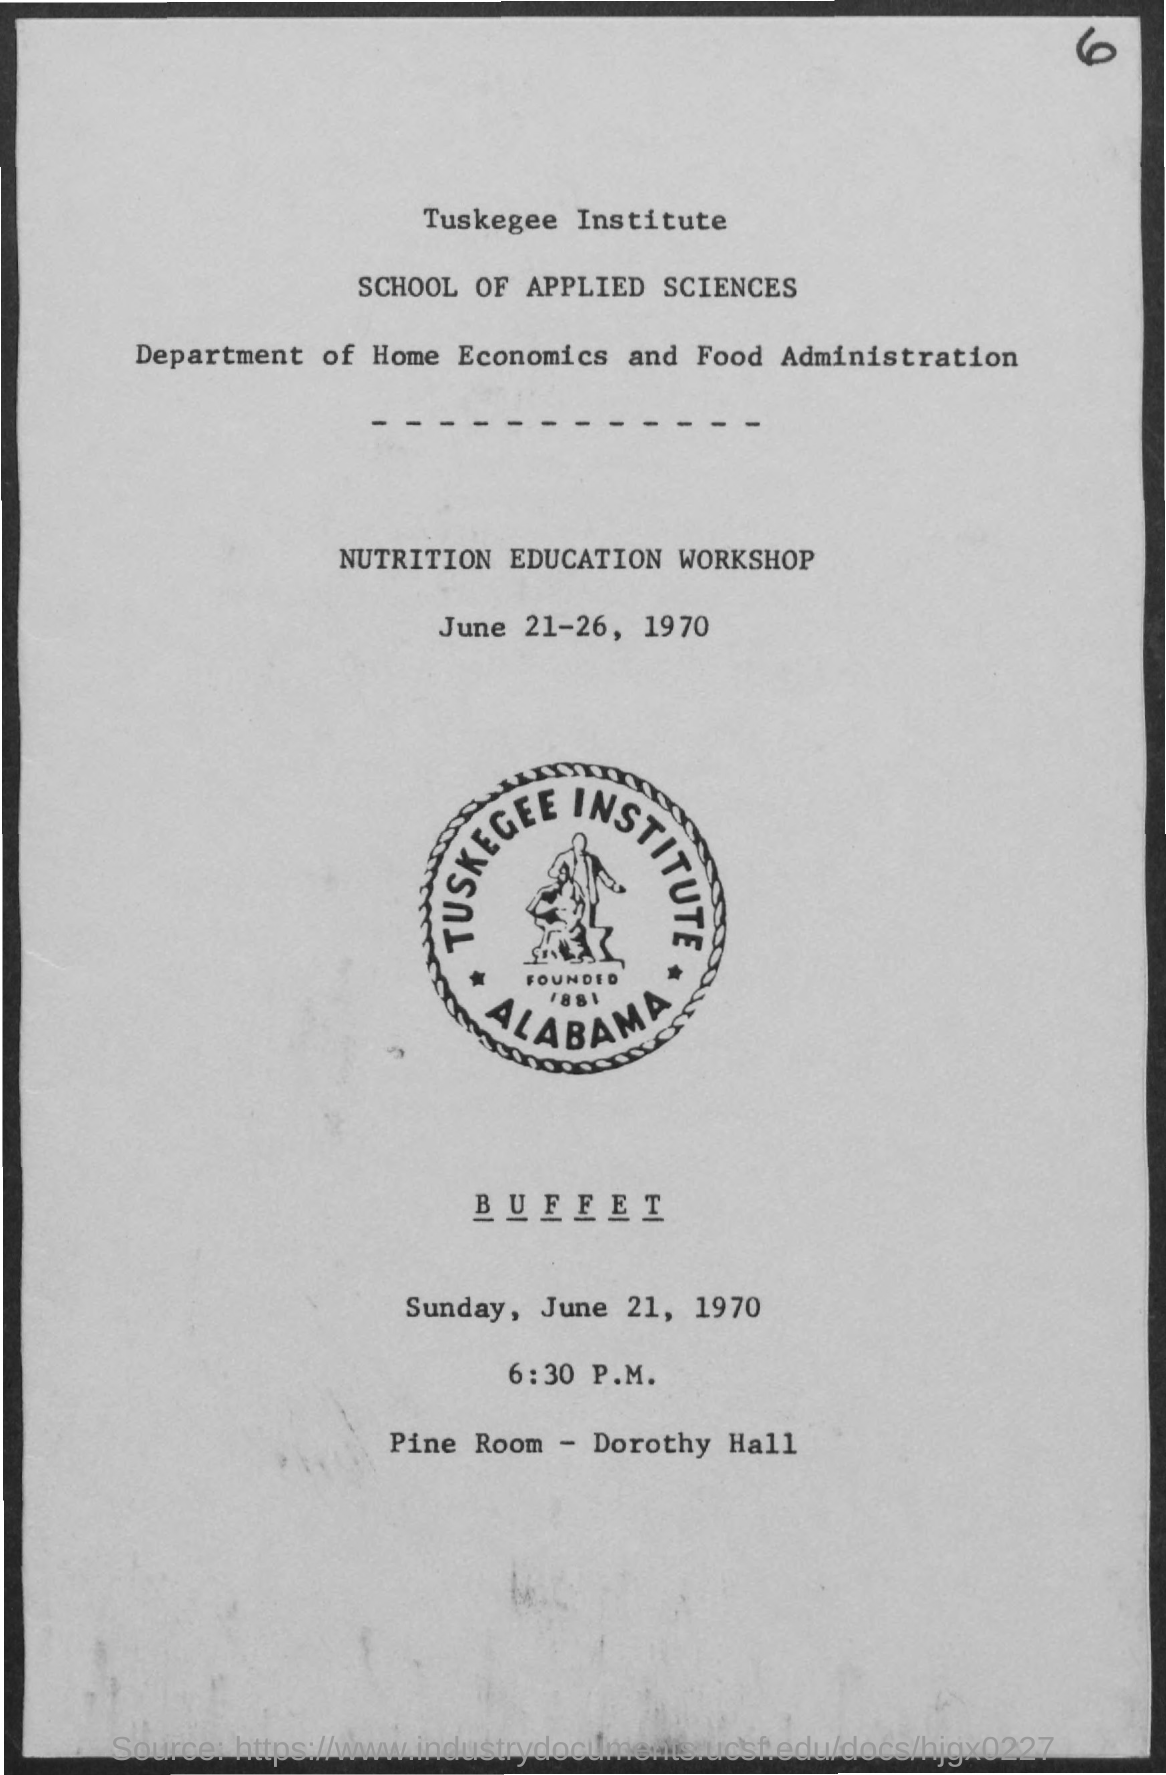Indicate a few pertinent items in this graphic. The location of the buffet is in the pine room of Dorothy Hall. The date of the buffet is Sunday, June 21, 1970. The Nutrition Education Workshop will take place from June 21 to 26, 1970. 